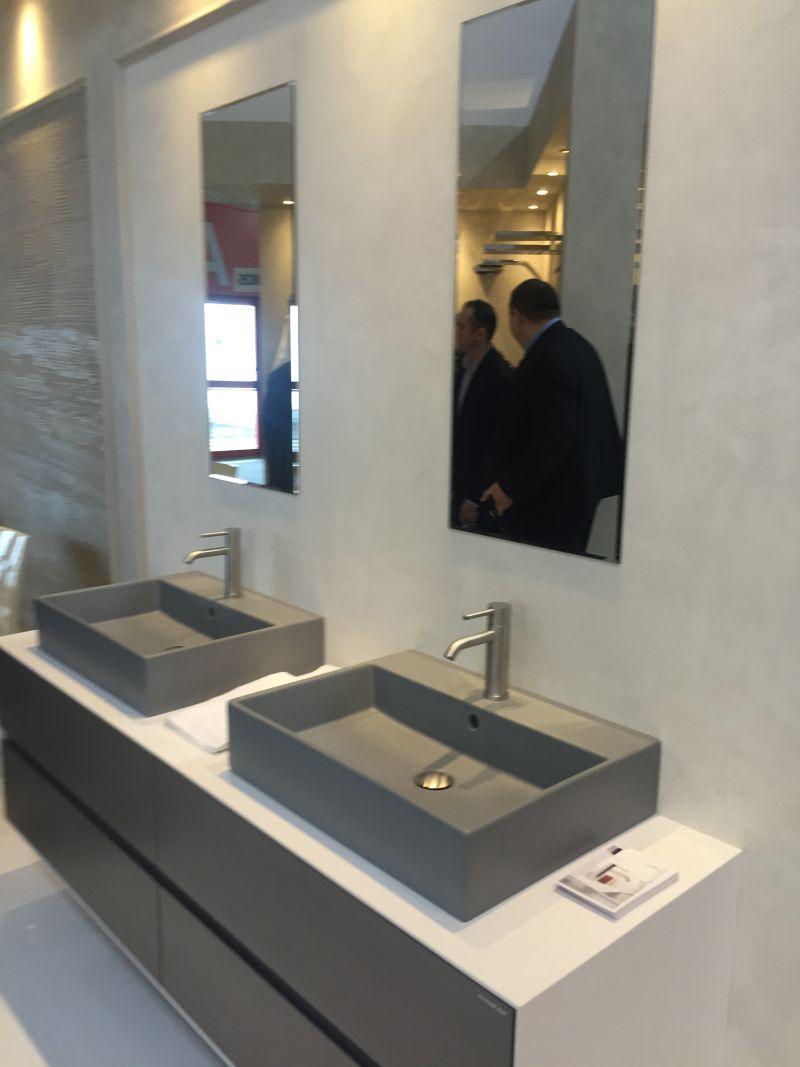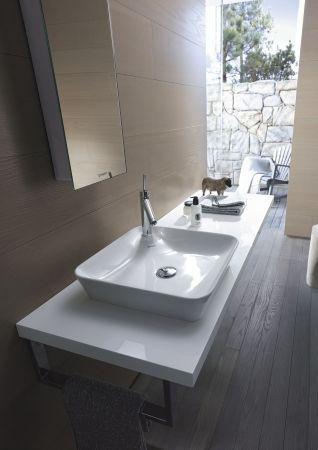The first image is the image on the left, the second image is the image on the right. For the images displayed, is the sentence "In total, three sink basins are shown." factually correct? Answer yes or no. Yes. The first image is the image on the left, the second image is the image on the right. Assess this claim about the two images: "Three faucets are attached directly to the sink porcelain.". Correct or not? Answer yes or no. Yes. 